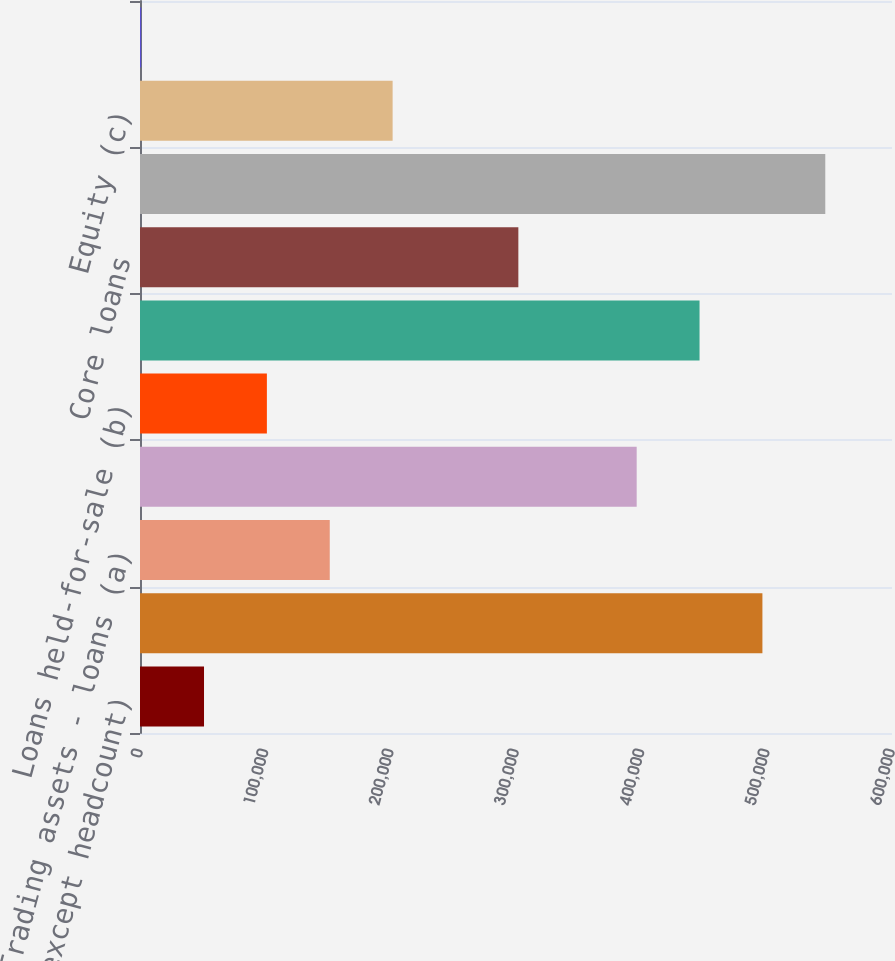Convert chart. <chart><loc_0><loc_0><loc_500><loc_500><bar_chart><fcel>(in millions except headcount)<fcel>Total assets<fcel>Trading assets - loans (a)<fcel>Loans retained<fcel>Loans held-for-sale (b)<fcel>Total loans<fcel>Core loans<fcel>Deposits<fcel>Equity (c)<fcel>Loans held-for-sale (d)<nl><fcel>51077.3<fcel>496609<fcel>151398<fcel>396288<fcel>101238<fcel>446448<fcel>301879<fcel>546769<fcel>201558<fcel>917<nl></chart> 